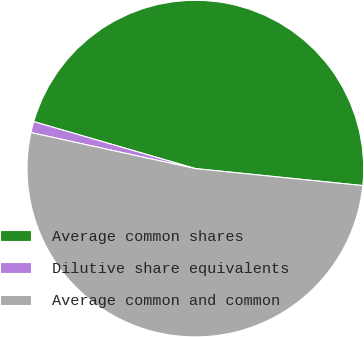Convert chart to OTSL. <chart><loc_0><loc_0><loc_500><loc_500><pie_chart><fcel>Average common shares<fcel>Dilutive share equivalents<fcel>Average common and common<nl><fcel>47.11%<fcel>1.07%<fcel>51.82%<nl></chart> 